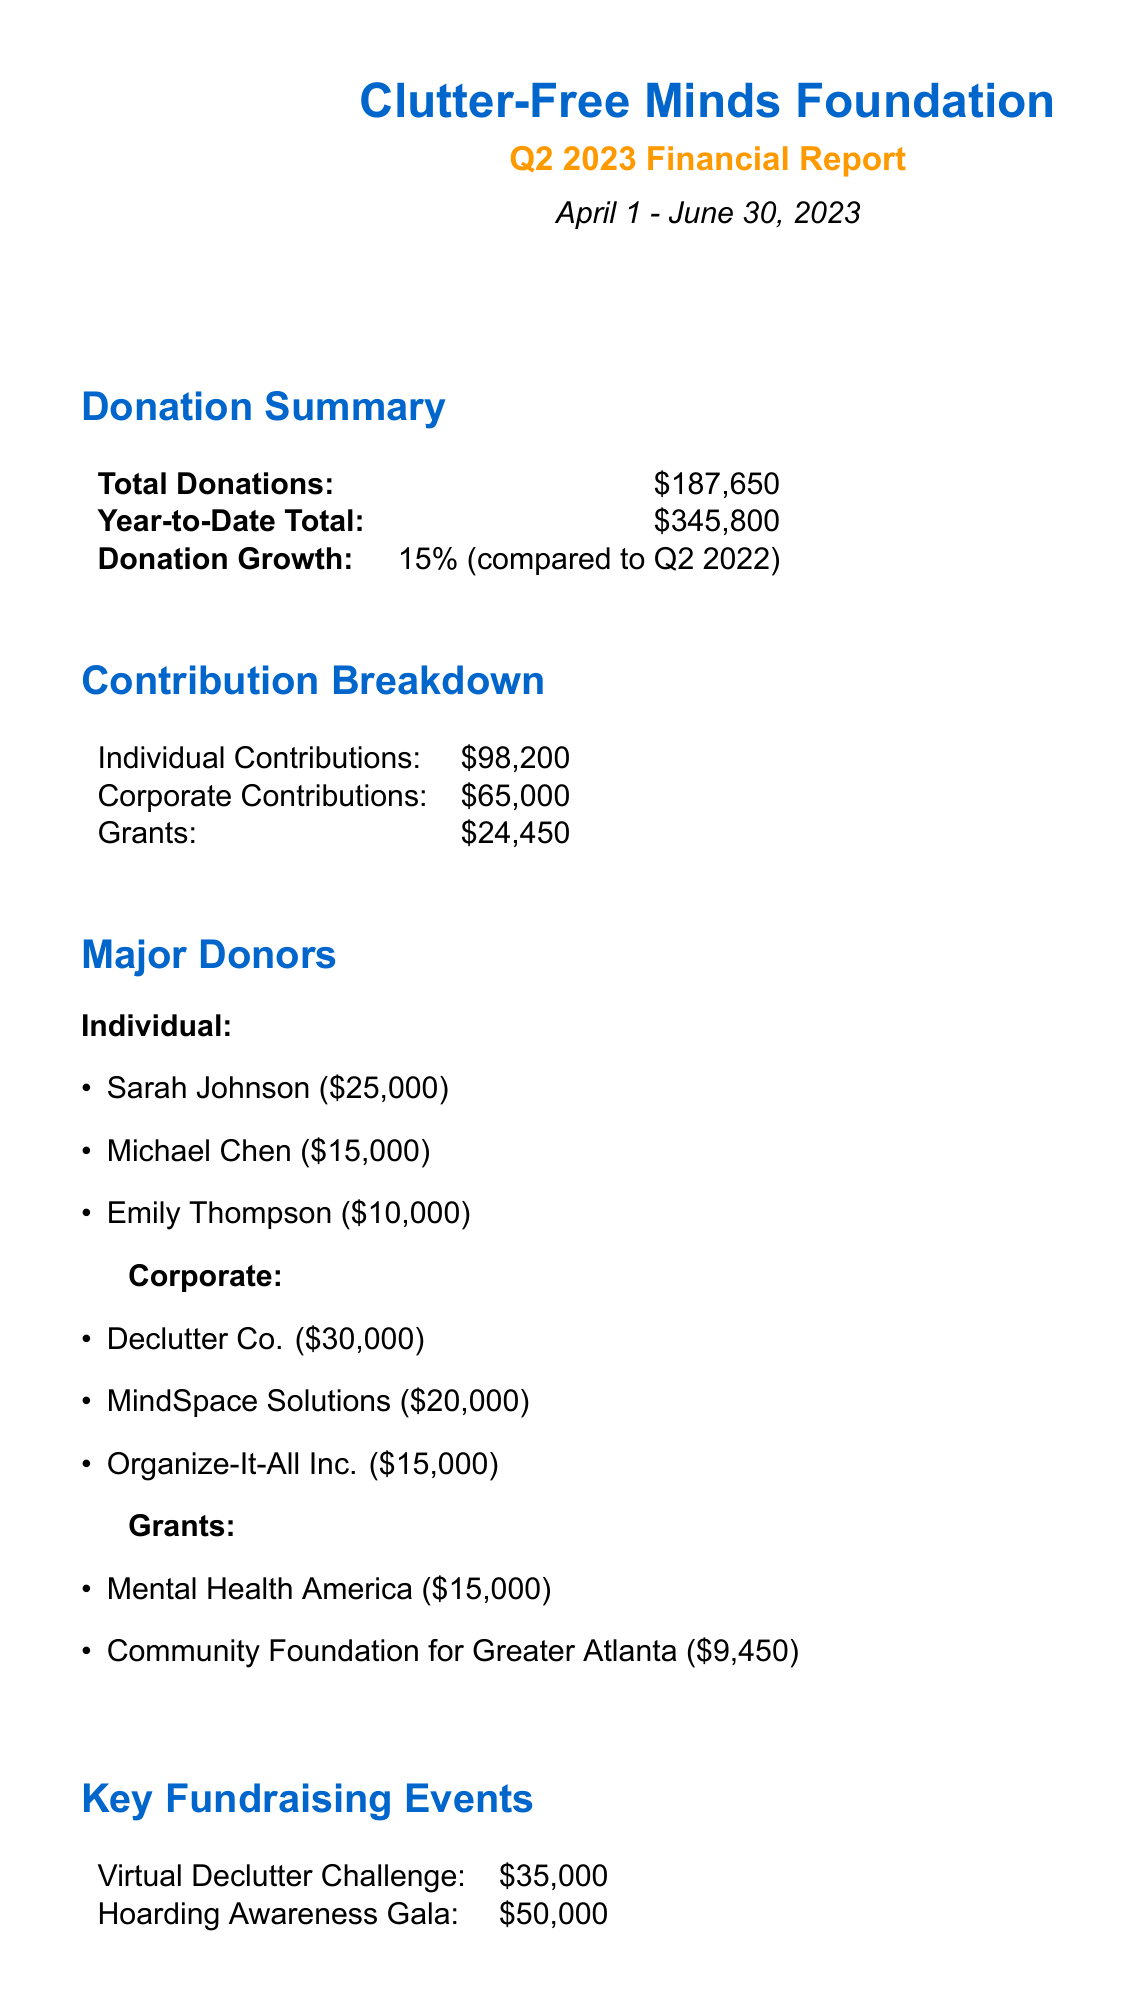What is the total amount of donations received in Q2 2023? The total donations received during Q2 2023 can be found in the Donation Summary section, which states a total of $187,650.
Answer: $187,650 What are the major individual contributions? The major individual contributions are listed in the Major Donors section under Individual, which includes Sarah Johnson, Michael Chen, and Emily Thompson with respective amounts of $25,000, $15,000, and $10,000.
Answer: Sarah Johnson, Michael Chen, Emily Thompson What was the growth percentage of donations compared to Q2 2022? The document mentions a donation growth percentage of 15% in the Donation Summary section when compared to Q2 2022.
Answer: 15% How much did Declutter Co. contribute? The amount contributed by Declutter Co. is specified in the Major Donors section under Corporate contributions, which is $30,000.
Answer: $30,000 What is the total amount of grants received? The total amount of grants received can be found in the Contribution Breakdown section, which states a total of $24,450.
Answer: $24,450 What key event raised the most funds? The key fundraising event that raised the most funds is mentioned under Key Fundraising Events, specifically stating the Hoarding Awareness Gala, which raised $50,000.
Answer: Hoarding Awareness Gala Which organization provided a grant of $15,000? The grant provided for $15,000 is stated in the Grants section from the source Mental Health America.
Answer: Mental Health America What are the two upcoming initiatives mentioned in the report? The upcoming initiatives listed in the document include launching online support groups for family members of hoarders and developing educational materials for mental health professionals.
Answer: Launch of online support groups for family members of hoarders, Development of educational materials for mental health professionals 